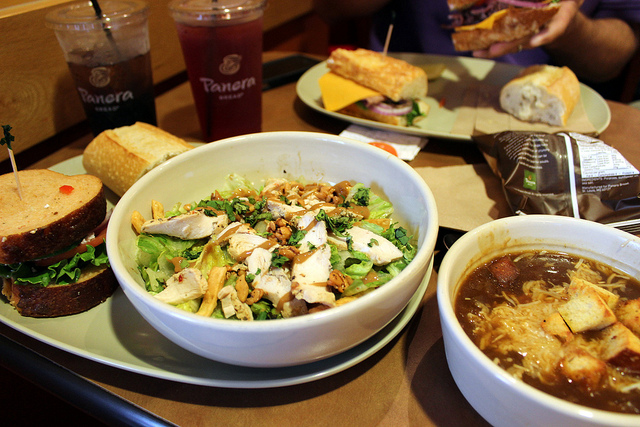<image>What restaurant is this? I don't know the exact restaurant but it could possibly be Panera or Olive Garden. What restaurant is this? It is ambiguous which restaurant this is. It could be Panera Bread or Tanora. 